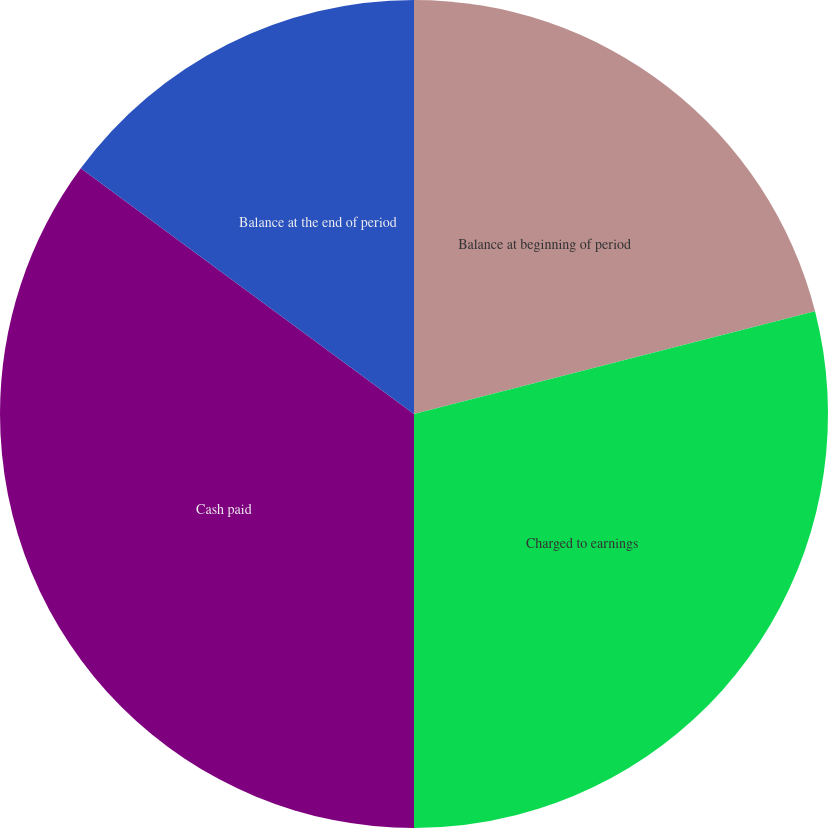Convert chart. <chart><loc_0><loc_0><loc_500><loc_500><pie_chart><fcel>Balance at beginning of period<fcel>Charged to earnings<fcel>Cash paid<fcel>Balance at the end of period<nl><fcel>21.01%<fcel>28.99%<fcel>35.11%<fcel>14.89%<nl></chart> 